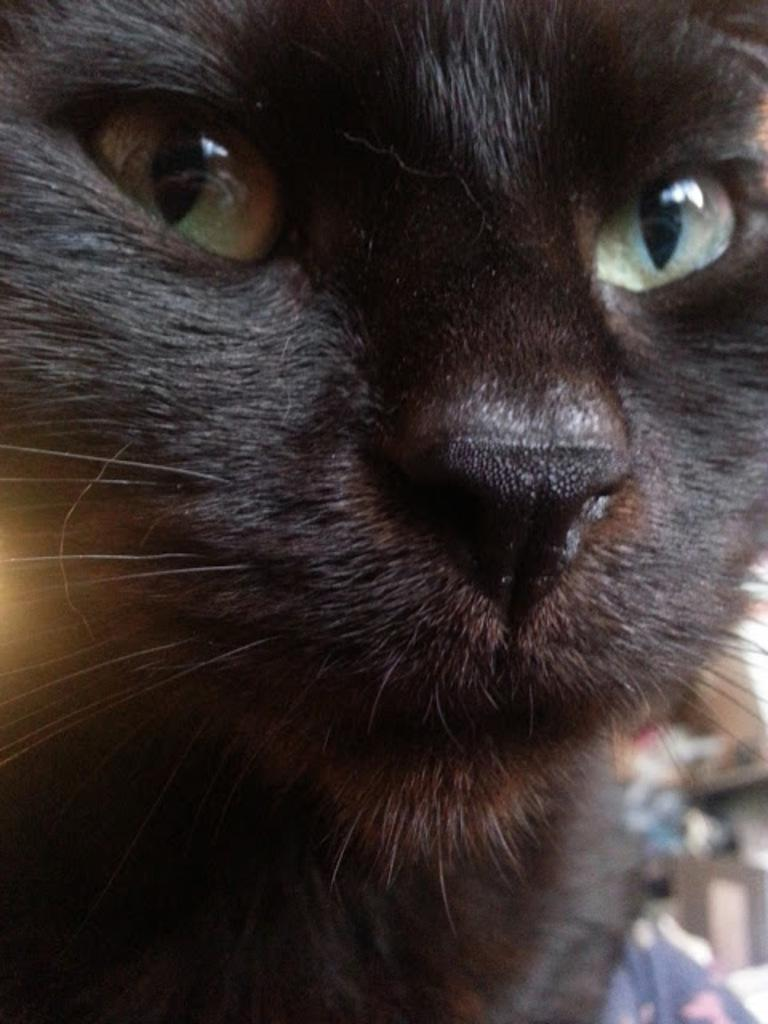What type of animal is present in the image? There is a cat in the image. Can you describe the color of the cat? The cat is black in color. What does the cat do to sort the laundry in the image? There is no laundry or sorting activity depicted in the image; it only features a black cat. 